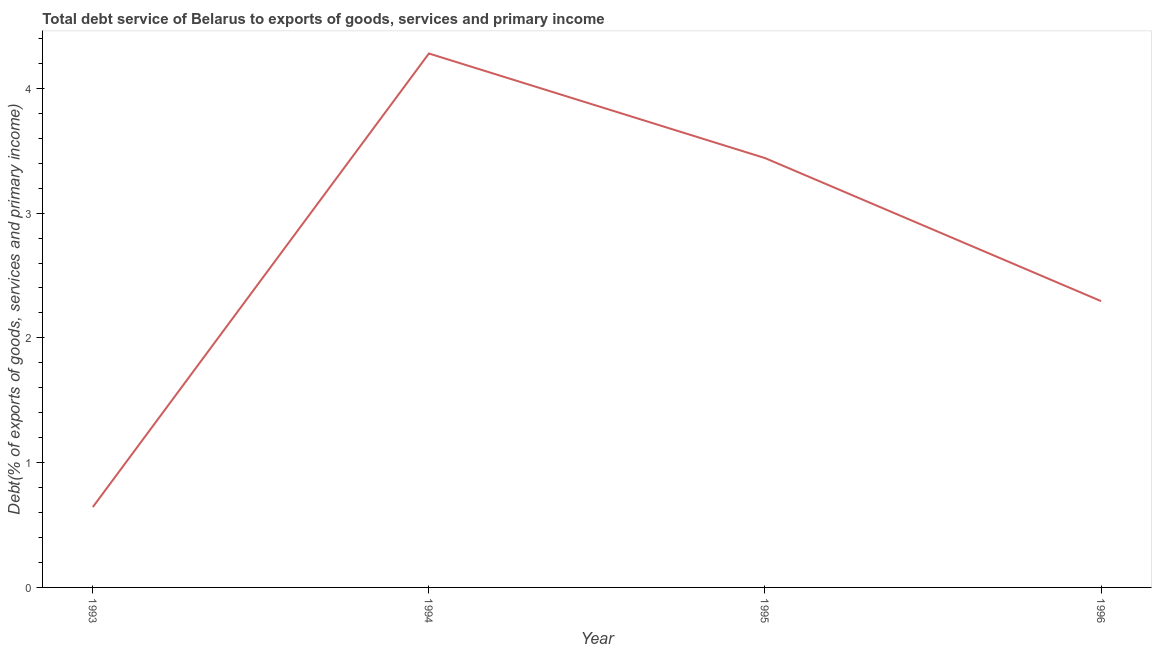What is the total debt service in 1994?
Offer a very short reply. 4.28. Across all years, what is the maximum total debt service?
Keep it short and to the point. 4.28. Across all years, what is the minimum total debt service?
Your answer should be compact. 0.64. In which year was the total debt service minimum?
Keep it short and to the point. 1993. What is the sum of the total debt service?
Make the answer very short. 10.66. What is the difference between the total debt service in 1993 and 1996?
Provide a short and direct response. -1.65. What is the average total debt service per year?
Provide a short and direct response. 2.66. What is the median total debt service?
Your answer should be compact. 2.87. In how many years, is the total debt service greater than 0.8 %?
Ensure brevity in your answer.  3. What is the ratio of the total debt service in 1995 to that in 1996?
Offer a terse response. 1.5. What is the difference between the highest and the second highest total debt service?
Make the answer very short. 0.84. What is the difference between the highest and the lowest total debt service?
Make the answer very short. 3.64. In how many years, is the total debt service greater than the average total debt service taken over all years?
Ensure brevity in your answer.  2. Does the total debt service monotonically increase over the years?
Your response must be concise. No. How many years are there in the graph?
Your response must be concise. 4. What is the difference between two consecutive major ticks on the Y-axis?
Your response must be concise. 1. Are the values on the major ticks of Y-axis written in scientific E-notation?
Provide a succinct answer. No. What is the title of the graph?
Make the answer very short. Total debt service of Belarus to exports of goods, services and primary income. What is the label or title of the Y-axis?
Your response must be concise. Debt(% of exports of goods, services and primary income). What is the Debt(% of exports of goods, services and primary income) of 1993?
Provide a succinct answer. 0.64. What is the Debt(% of exports of goods, services and primary income) in 1994?
Keep it short and to the point. 4.28. What is the Debt(% of exports of goods, services and primary income) in 1995?
Offer a terse response. 3.44. What is the Debt(% of exports of goods, services and primary income) in 1996?
Ensure brevity in your answer.  2.29. What is the difference between the Debt(% of exports of goods, services and primary income) in 1993 and 1994?
Provide a succinct answer. -3.64. What is the difference between the Debt(% of exports of goods, services and primary income) in 1993 and 1995?
Your answer should be very brief. -2.8. What is the difference between the Debt(% of exports of goods, services and primary income) in 1993 and 1996?
Your answer should be very brief. -1.65. What is the difference between the Debt(% of exports of goods, services and primary income) in 1994 and 1995?
Your response must be concise. 0.84. What is the difference between the Debt(% of exports of goods, services and primary income) in 1994 and 1996?
Provide a short and direct response. 1.98. What is the difference between the Debt(% of exports of goods, services and primary income) in 1995 and 1996?
Your response must be concise. 1.15. What is the ratio of the Debt(% of exports of goods, services and primary income) in 1993 to that in 1995?
Your answer should be compact. 0.19. What is the ratio of the Debt(% of exports of goods, services and primary income) in 1993 to that in 1996?
Your answer should be compact. 0.28. What is the ratio of the Debt(% of exports of goods, services and primary income) in 1994 to that in 1995?
Ensure brevity in your answer.  1.24. What is the ratio of the Debt(% of exports of goods, services and primary income) in 1994 to that in 1996?
Give a very brief answer. 1.86. 